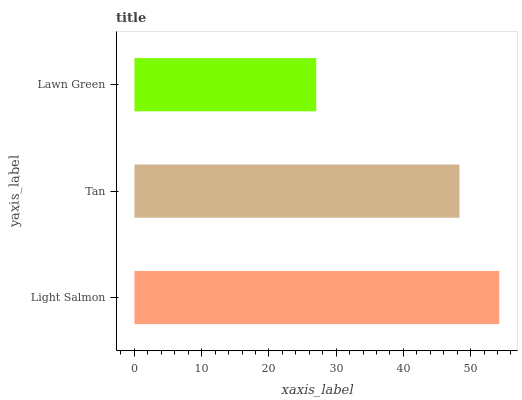Is Lawn Green the minimum?
Answer yes or no. Yes. Is Light Salmon the maximum?
Answer yes or no. Yes. Is Tan the minimum?
Answer yes or no. No. Is Tan the maximum?
Answer yes or no. No. Is Light Salmon greater than Tan?
Answer yes or no. Yes. Is Tan less than Light Salmon?
Answer yes or no. Yes. Is Tan greater than Light Salmon?
Answer yes or no. No. Is Light Salmon less than Tan?
Answer yes or no. No. Is Tan the high median?
Answer yes or no. Yes. Is Tan the low median?
Answer yes or no. Yes. Is Light Salmon the high median?
Answer yes or no. No. Is Light Salmon the low median?
Answer yes or no. No. 